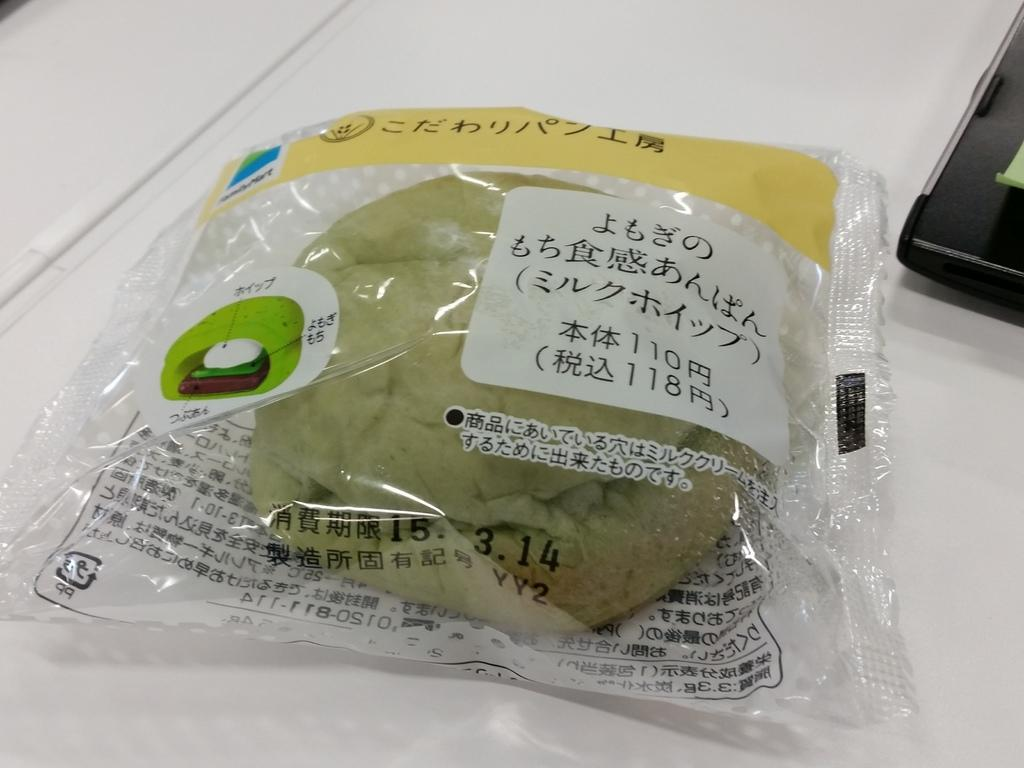What is placed inside the cover in the image? The facts do not specify what is placed inside the cover. What can be read on the cover? The cover has something written on it. Can you describe the black color object in the image? There is a black color object in the right top corner of the image. What type of education can be seen in the image? There is no indication of education in the image. How much noise is present in the image? The image does not provide any information about noise levels. 